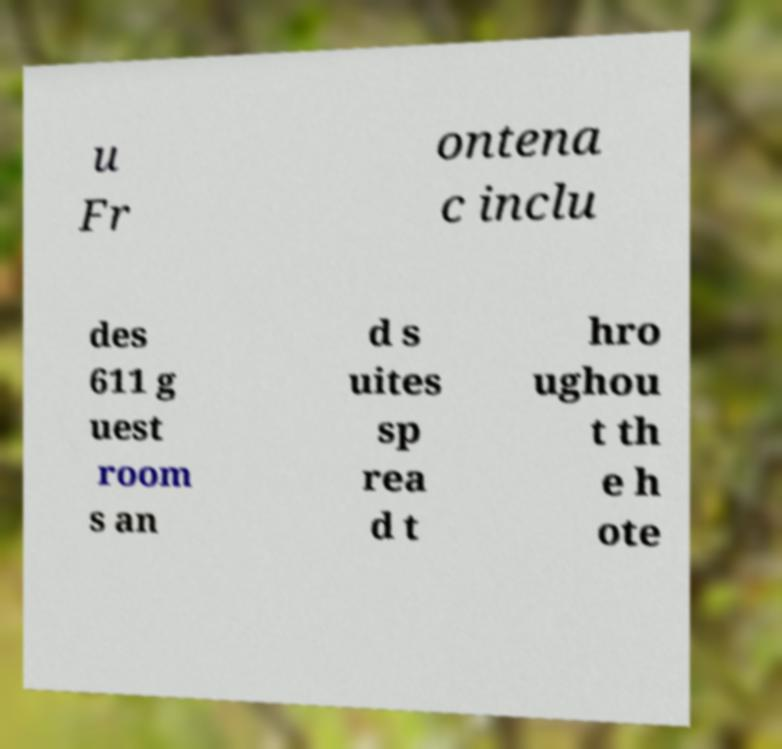Can you read and provide the text displayed in the image?This photo seems to have some interesting text. Can you extract and type it out for me? u Fr ontena c inclu des 611 g uest room s an d s uites sp rea d t hro ughou t th e h ote 